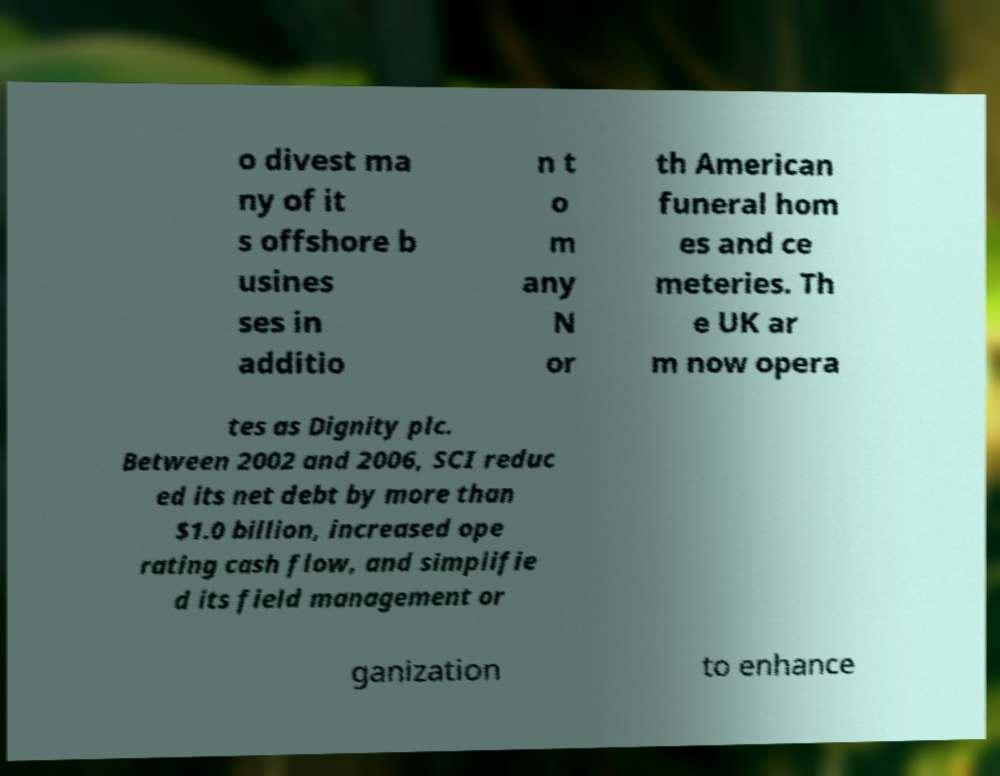Can you read and provide the text displayed in the image?This photo seems to have some interesting text. Can you extract and type it out for me? o divest ma ny of it s offshore b usines ses in additio n t o m any N or th American funeral hom es and ce meteries. Th e UK ar m now opera tes as Dignity plc. Between 2002 and 2006, SCI reduc ed its net debt by more than $1.0 billion, increased ope rating cash flow, and simplifie d its field management or ganization to enhance 